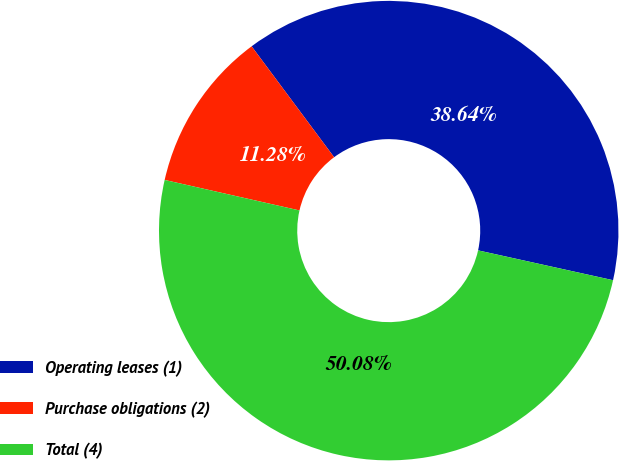Convert chart. <chart><loc_0><loc_0><loc_500><loc_500><pie_chart><fcel>Operating leases (1)<fcel>Purchase obligations (2)<fcel>Total (4)<nl><fcel>38.64%<fcel>11.28%<fcel>50.08%<nl></chart> 